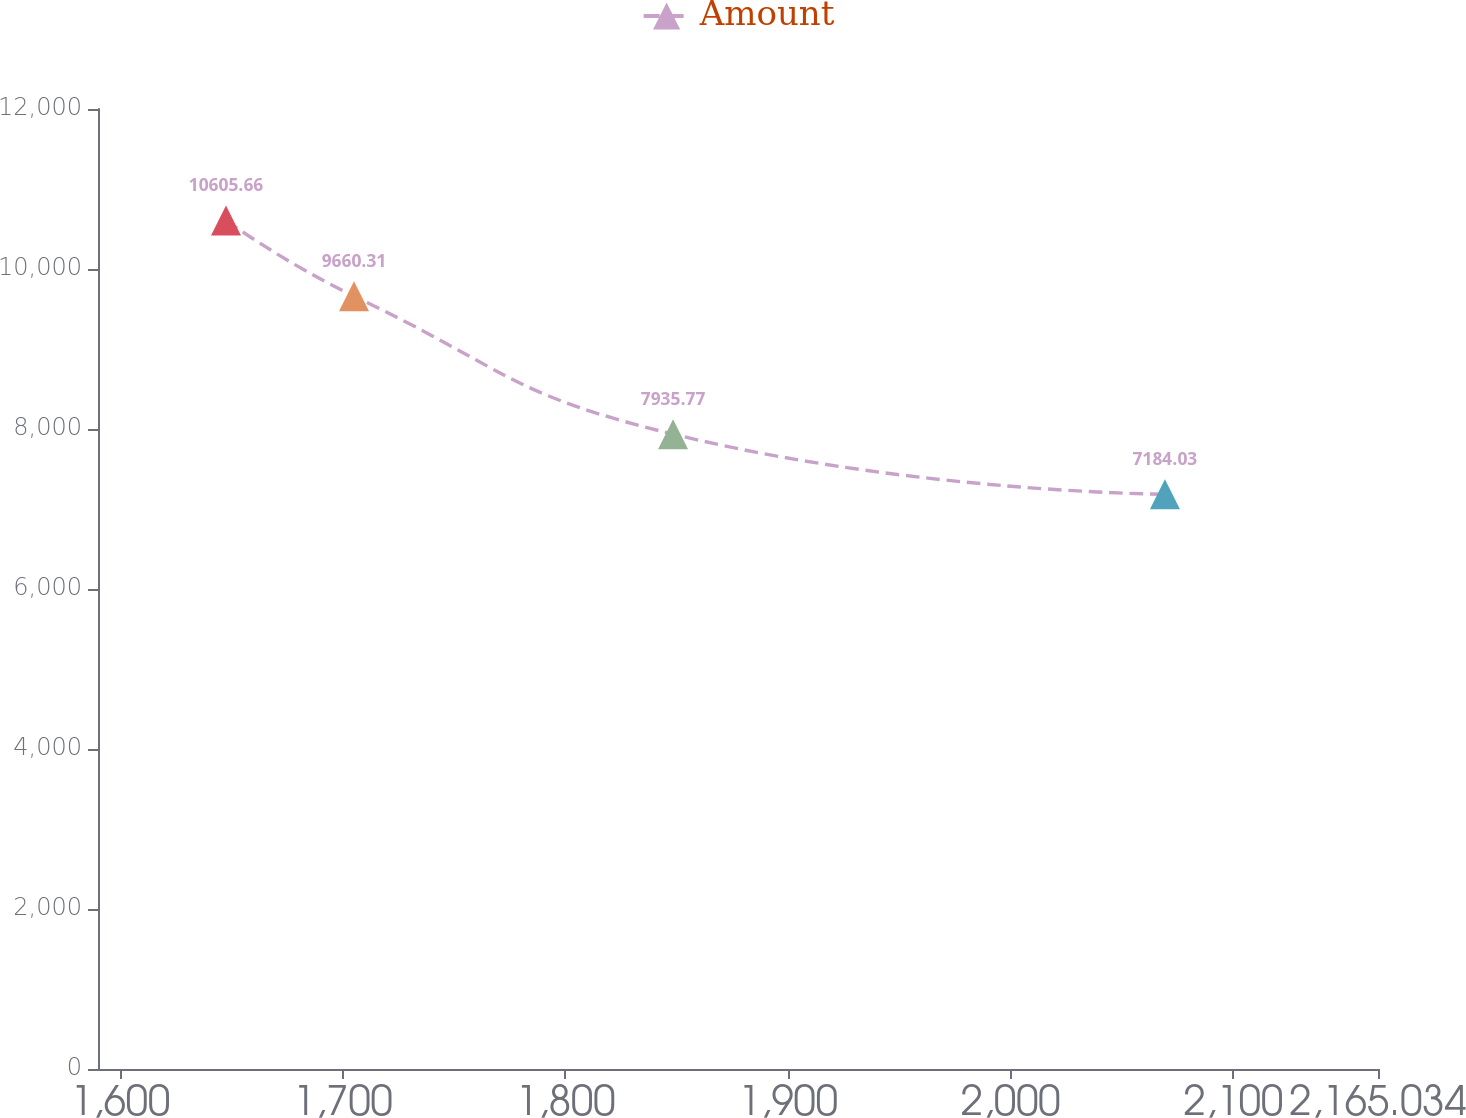Convert chart. <chart><loc_0><loc_0><loc_500><loc_500><line_chart><ecel><fcel>Amount<nl><fcel>1647.48<fcel>10605.7<nl><fcel>1704.99<fcel>9660.31<nl><fcel>1848.33<fcel>7935.77<nl><fcel>2069.3<fcel>7184.03<nl><fcel>2222.54<fcel>10002.5<nl></chart> 